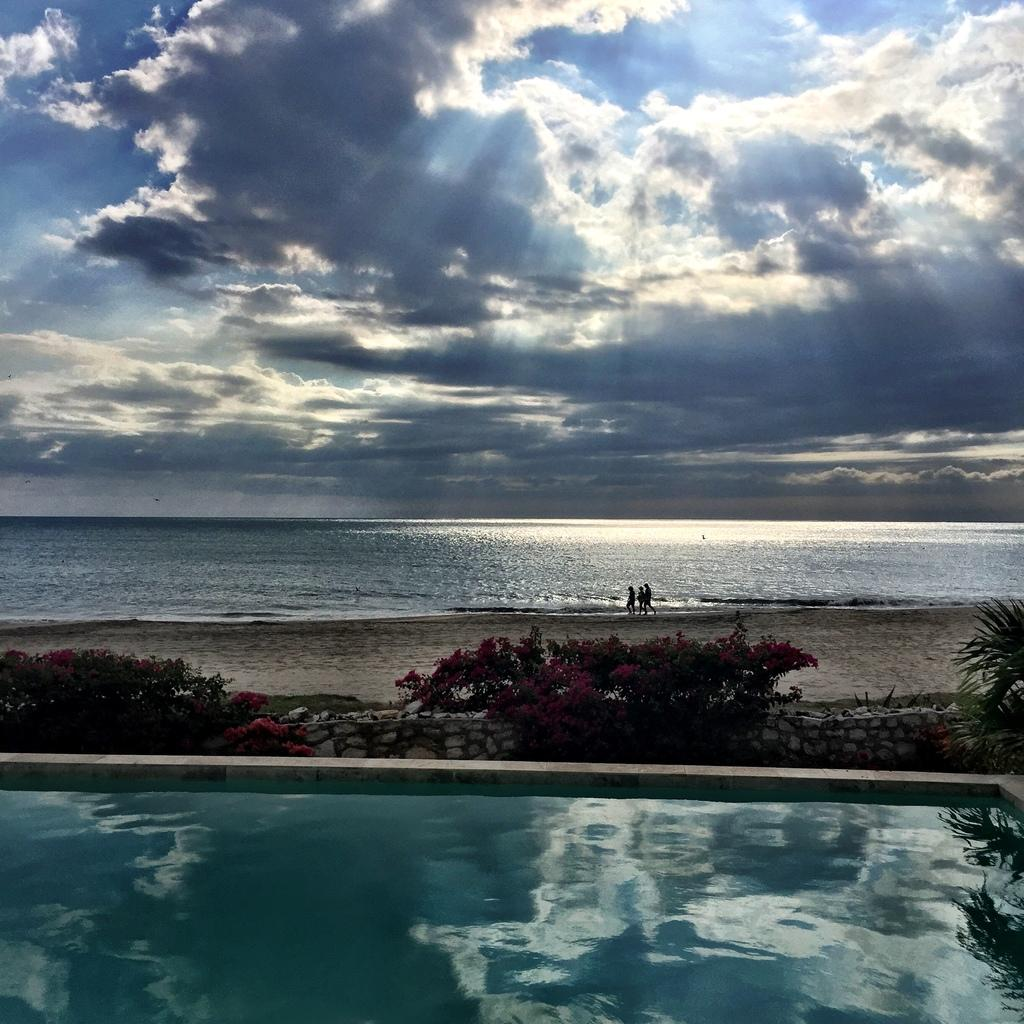What is located in the foreground of the image? There is a pool in the foreground of the image. What type of plants can be seen in the image? There are flower plants in the image. Where are the people situated in the image? The people are on the side of a beach in the image. What is the primary element visible in the image? There is water visible in the image. What can be seen in the sky in the image? There are clouds in the sky in the image. Where is the curtain located in the image? There is no curtain present in the image. What type of drawer can be seen in the image? There is no drawer present in the image. 